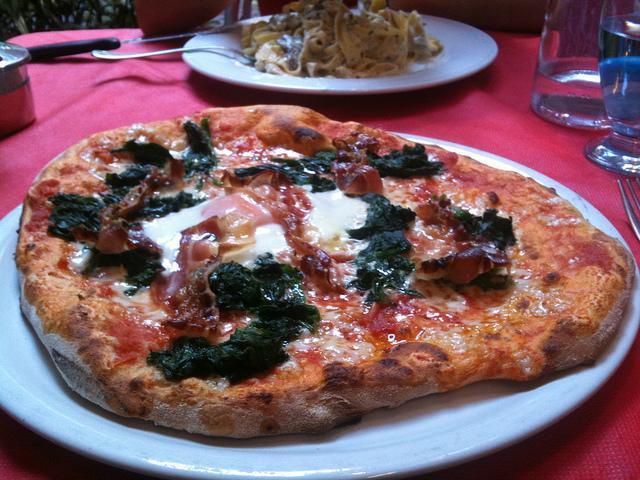How many pizzas are in the photo?
Give a very brief answer. 1. How many cups can you see?
Give a very brief answer. 2. How many pink iced donuts are left?
Give a very brief answer. 0. 